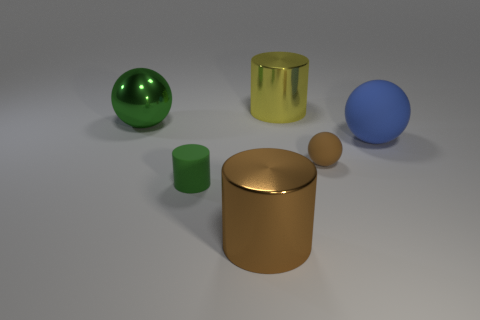Add 3 yellow blocks. How many objects exist? 9 Subtract 1 green spheres. How many objects are left? 5 Subtract all brown objects. Subtract all small green cylinders. How many objects are left? 3 Add 6 brown cylinders. How many brown cylinders are left? 7 Add 5 small gray objects. How many small gray objects exist? 5 